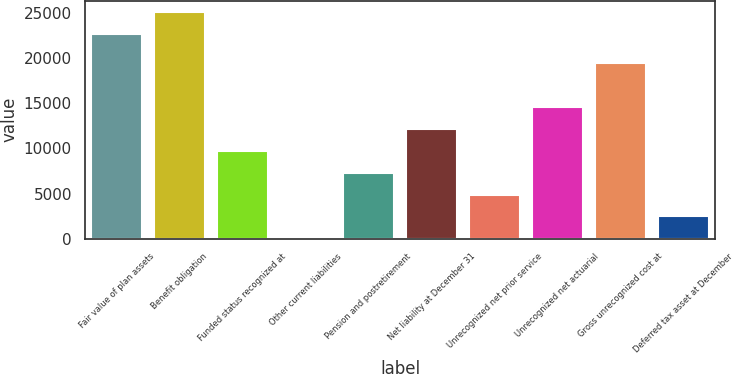Convert chart. <chart><loc_0><loc_0><loc_500><loc_500><bar_chart><fcel>Fair value of plan assets<fcel>Benefit obligation<fcel>Funded status recognized at<fcel>Other current liabilities<fcel>Pension and postretirement<fcel>Net liability at December 31<fcel>Unrecognized net prior service<fcel>Unrecognized net actuarial<fcel>Gross unrecognized cost at<fcel>Deferred tax asset at December<nl><fcel>22663<fcel>25100.3<fcel>9762.2<fcel>13<fcel>7324.9<fcel>12199.5<fcel>4887.6<fcel>14636.8<fcel>19511.4<fcel>2450.3<nl></chart> 